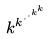<formula> <loc_0><loc_0><loc_500><loc_500>k ^ { k ^ { \cdot ^ { \cdot ^ { k ^ { k } } } } }</formula> 